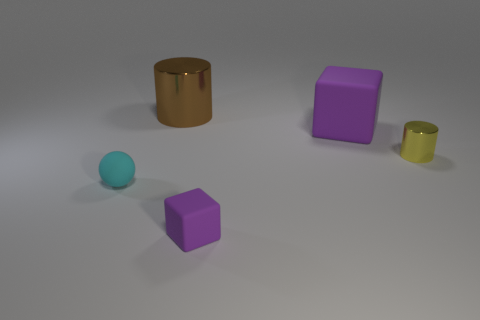Is the small cylinder made of the same material as the block that is behind the cyan object?
Offer a very short reply. No. Is the shape of the small cyan object the same as the large metallic object?
Give a very brief answer. No. What number of other things are made of the same material as the tiny cube?
Your answer should be compact. 2. How many yellow objects are the same shape as the brown thing?
Keep it short and to the point. 1. The small object that is both behind the small purple rubber block and right of the brown thing is what color?
Your answer should be compact. Yellow. How many purple matte objects are there?
Ensure brevity in your answer.  2. Is the brown shiny cylinder the same size as the yellow object?
Provide a short and direct response. No. Are there any large cylinders of the same color as the small rubber ball?
Your answer should be very brief. No. Is the shape of the tiny matte object in front of the tiny cyan sphere the same as  the yellow shiny thing?
Make the answer very short. No. How many yellow cylinders are the same size as the cyan rubber object?
Keep it short and to the point. 1. 